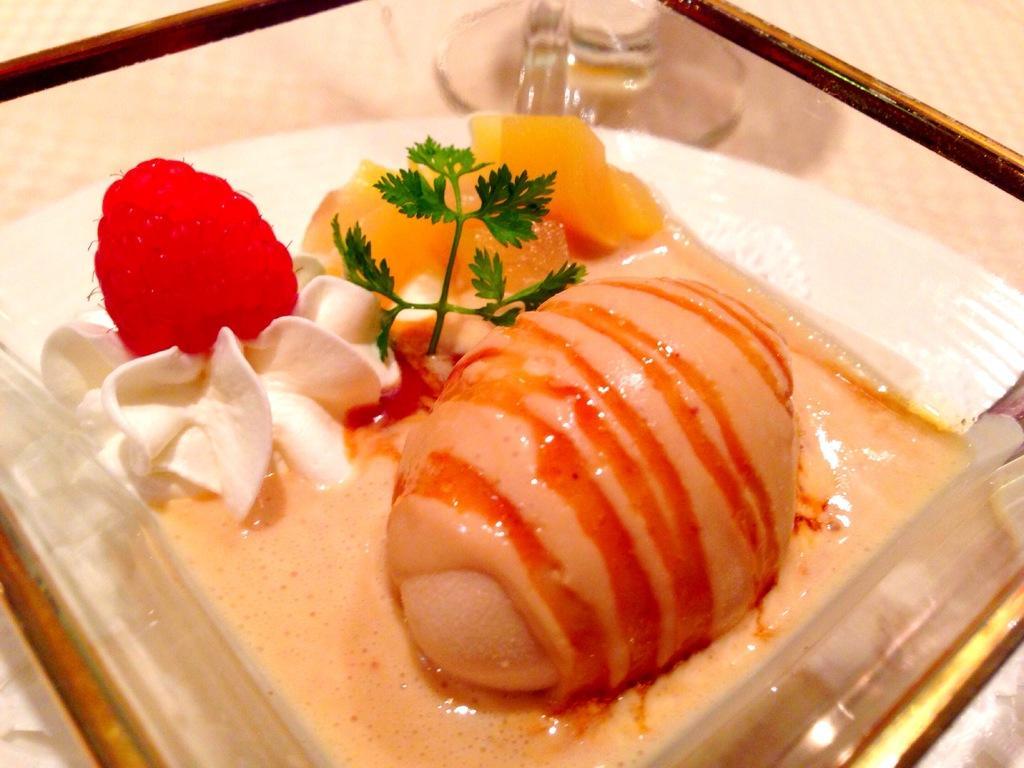In one or two sentences, can you explain what this image depicts? This image consists of food. 